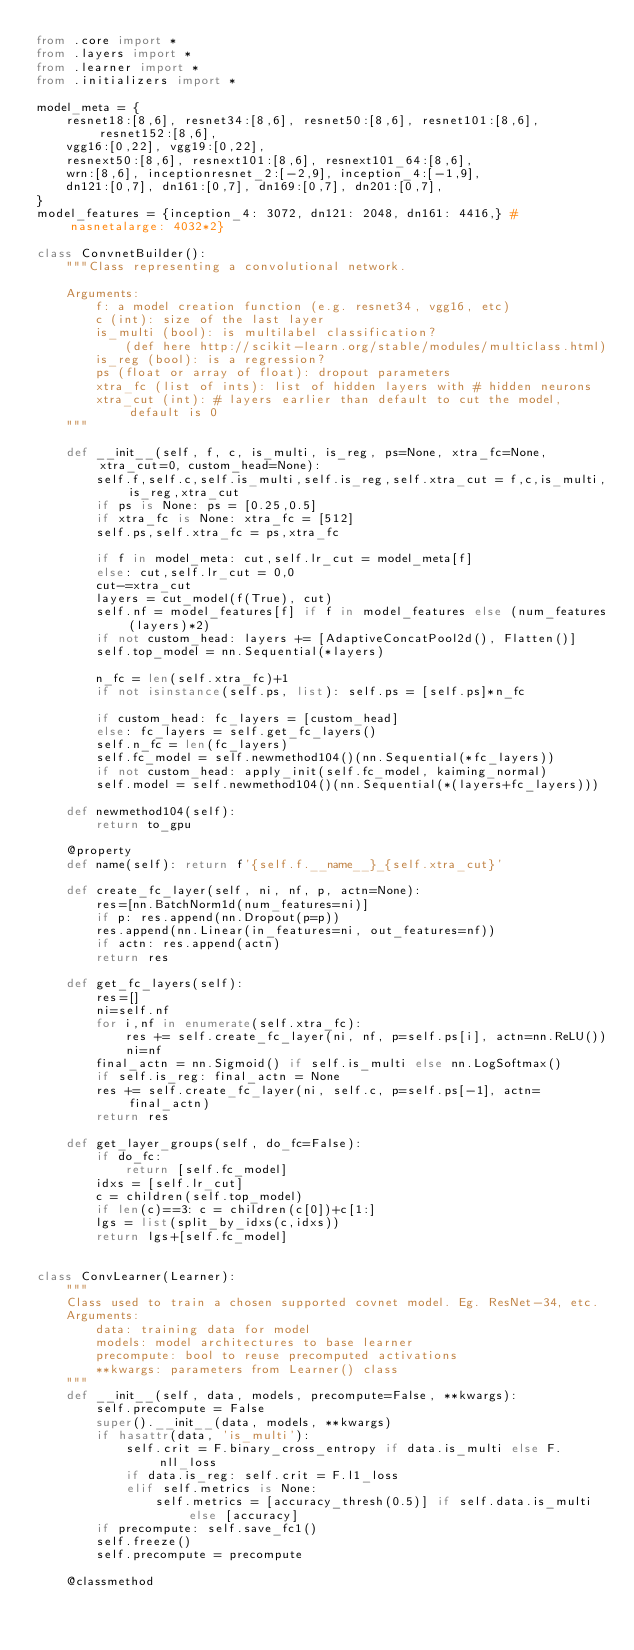Convert code to text. <code><loc_0><loc_0><loc_500><loc_500><_Python_>from .core import *
from .layers import *
from .learner import *
from .initializers import *

model_meta = {
    resnet18:[8,6], resnet34:[8,6], resnet50:[8,6], resnet101:[8,6], resnet152:[8,6],
    vgg16:[0,22], vgg19:[0,22],
    resnext50:[8,6], resnext101:[8,6], resnext101_64:[8,6],
    wrn:[8,6], inceptionresnet_2:[-2,9], inception_4:[-1,9],
    dn121:[0,7], dn161:[0,7], dn169:[0,7], dn201:[0,7],
}
model_features = {inception_4: 3072, dn121: 2048, dn161: 4416,} # nasnetalarge: 4032*2}

class ConvnetBuilder():
    """Class representing a convolutional network.

    Arguments:
        f: a model creation function (e.g. resnet34, vgg16, etc)
        c (int): size of the last layer
        is_multi (bool): is multilabel classification?
            (def here http://scikit-learn.org/stable/modules/multiclass.html)
        is_reg (bool): is a regression?
        ps (float or array of float): dropout parameters
        xtra_fc (list of ints): list of hidden layers with # hidden neurons
        xtra_cut (int): # layers earlier than default to cut the model, default is 0
    """

    def __init__(self, f, c, is_multi, is_reg, ps=None, xtra_fc=None, xtra_cut=0, custom_head=None):
        self.f,self.c,self.is_multi,self.is_reg,self.xtra_cut = f,c,is_multi,is_reg,xtra_cut
        if ps is None: ps = [0.25,0.5]
        if xtra_fc is None: xtra_fc = [512]
        self.ps,self.xtra_fc = ps,xtra_fc

        if f in model_meta: cut,self.lr_cut = model_meta[f]
        else: cut,self.lr_cut = 0,0
        cut-=xtra_cut
        layers = cut_model(f(True), cut)
        self.nf = model_features[f] if f in model_features else (num_features(layers)*2)
        if not custom_head: layers += [AdaptiveConcatPool2d(), Flatten()]
        self.top_model = nn.Sequential(*layers)

        n_fc = len(self.xtra_fc)+1
        if not isinstance(self.ps, list): self.ps = [self.ps]*n_fc

        if custom_head: fc_layers = [custom_head]
        else: fc_layers = self.get_fc_layers()
        self.n_fc = len(fc_layers)
        self.fc_model = self.newmethod104()(nn.Sequential(*fc_layers))
        if not custom_head: apply_init(self.fc_model, kaiming_normal)
        self.model = self.newmethod104()(nn.Sequential(*(layers+fc_layers)))

    def newmethod104(self):
        return to_gpu

    @property
    def name(self): return f'{self.f.__name__}_{self.xtra_cut}'

    def create_fc_layer(self, ni, nf, p, actn=None):
        res=[nn.BatchNorm1d(num_features=ni)]
        if p: res.append(nn.Dropout(p=p))
        res.append(nn.Linear(in_features=ni, out_features=nf))
        if actn: res.append(actn)
        return res

    def get_fc_layers(self):
        res=[]
        ni=self.nf
        for i,nf in enumerate(self.xtra_fc):
            res += self.create_fc_layer(ni, nf, p=self.ps[i], actn=nn.ReLU())
            ni=nf
        final_actn = nn.Sigmoid() if self.is_multi else nn.LogSoftmax()
        if self.is_reg: final_actn = None
        res += self.create_fc_layer(ni, self.c, p=self.ps[-1], actn=final_actn)
        return res

    def get_layer_groups(self, do_fc=False):
        if do_fc:
            return [self.fc_model]
        idxs = [self.lr_cut]
        c = children(self.top_model)
        if len(c)==3: c = children(c[0])+c[1:]
        lgs = list(split_by_idxs(c,idxs))
        return lgs+[self.fc_model]


class ConvLearner(Learner):
    """
    Class used to train a chosen supported covnet model. Eg. ResNet-34, etc.
    Arguments:
        data: training data for model
        models: model architectures to base learner
        precompute: bool to reuse precomputed activations
        **kwargs: parameters from Learner() class
    """
    def __init__(self, data, models, precompute=False, **kwargs):
        self.precompute = False
        super().__init__(data, models, **kwargs)
        if hasattr(data, 'is_multi'):
            self.crit = F.binary_cross_entropy if data.is_multi else F.nll_loss
            if data.is_reg: self.crit = F.l1_loss
            elif self.metrics is None:
                self.metrics = [accuracy_thresh(0.5)] if self.data.is_multi else [accuracy]
        if precompute: self.save_fc1()
        self.freeze()
        self.precompute = precompute

    @classmethod</code> 